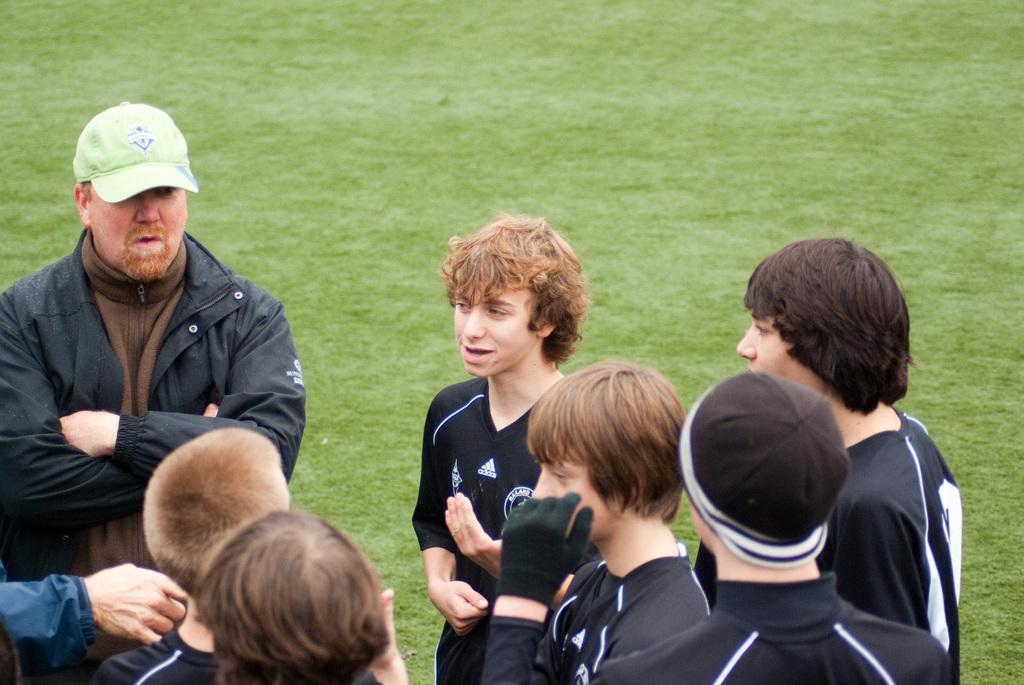What is the surface that the people are standing on in the image? The ground is covered with grass in the image. What are the people wearing in the image? There are no specific details about the clothing of the people, but a man is wearing a jacket and a cap. Can you describe the man's outfit in more detail? The man is wearing a jacket and a cap in the image. What type of cub can be seen playing with the lumber in the image? There is no cub or lumber present in the image. Is the minister in the image wearing a robe? There is no minister present in the image, so it is not possible to determine what they might be wearing. 